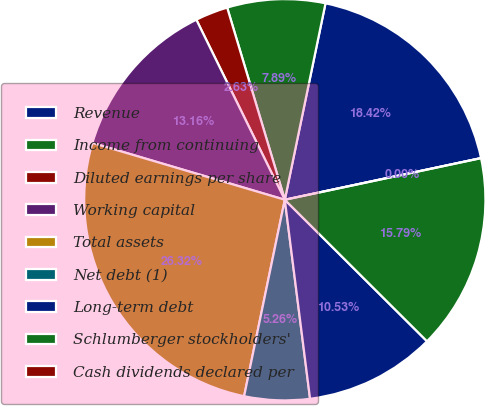Convert chart to OTSL. <chart><loc_0><loc_0><loc_500><loc_500><pie_chart><fcel>Revenue<fcel>Income from continuing<fcel>Diluted earnings per share<fcel>Working capital<fcel>Total assets<fcel>Net debt (1)<fcel>Long-term debt<fcel>Schlumberger stockholders'<fcel>Cash dividends declared per<nl><fcel>18.42%<fcel>7.89%<fcel>2.63%<fcel>13.16%<fcel>26.32%<fcel>5.26%<fcel>10.53%<fcel>15.79%<fcel>0.0%<nl></chart> 